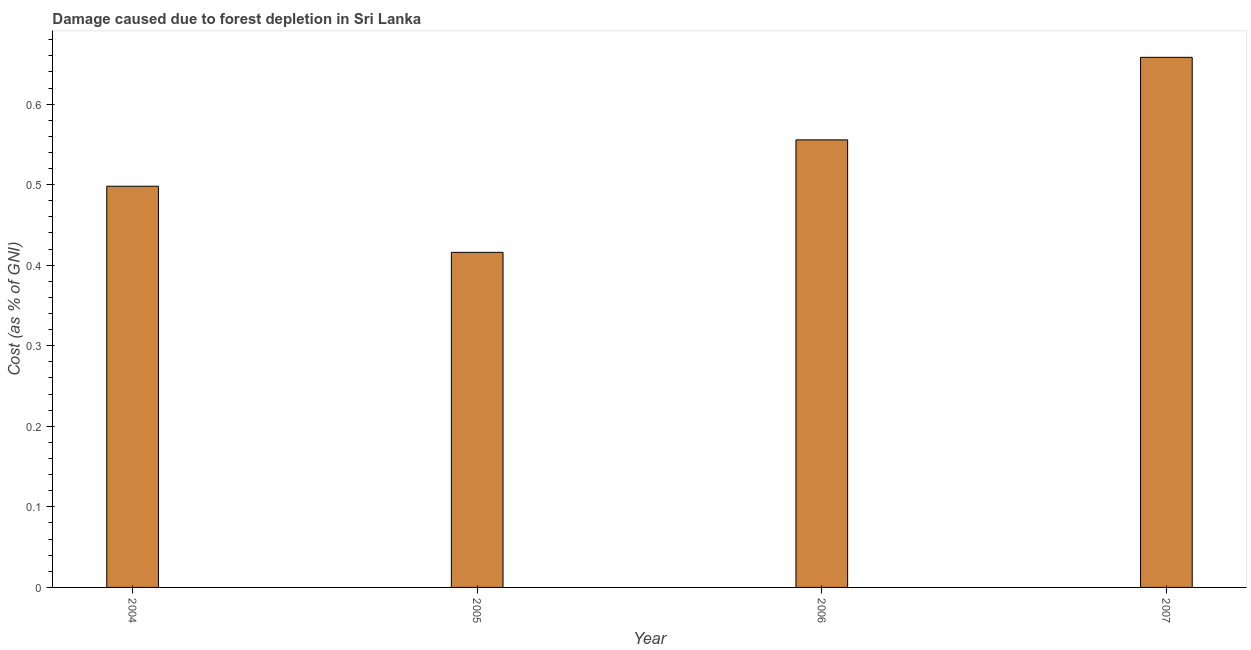What is the title of the graph?
Offer a very short reply. Damage caused due to forest depletion in Sri Lanka. What is the label or title of the X-axis?
Offer a very short reply. Year. What is the label or title of the Y-axis?
Keep it short and to the point. Cost (as % of GNI). What is the damage caused due to forest depletion in 2007?
Your response must be concise. 0.66. Across all years, what is the maximum damage caused due to forest depletion?
Your response must be concise. 0.66. Across all years, what is the minimum damage caused due to forest depletion?
Your answer should be compact. 0.42. What is the sum of the damage caused due to forest depletion?
Provide a short and direct response. 2.13. What is the difference between the damage caused due to forest depletion in 2004 and 2007?
Provide a succinct answer. -0.16. What is the average damage caused due to forest depletion per year?
Provide a succinct answer. 0.53. What is the median damage caused due to forest depletion?
Make the answer very short. 0.53. In how many years, is the damage caused due to forest depletion greater than 0.38 %?
Give a very brief answer. 4. What is the ratio of the damage caused due to forest depletion in 2006 to that in 2007?
Keep it short and to the point. 0.84. Is the difference between the damage caused due to forest depletion in 2004 and 2006 greater than the difference between any two years?
Ensure brevity in your answer.  No. What is the difference between the highest and the second highest damage caused due to forest depletion?
Provide a succinct answer. 0.1. Is the sum of the damage caused due to forest depletion in 2004 and 2007 greater than the maximum damage caused due to forest depletion across all years?
Provide a short and direct response. Yes. What is the difference between the highest and the lowest damage caused due to forest depletion?
Ensure brevity in your answer.  0.24. How many bars are there?
Offer a terse response. 4. Are all the bars in the graph horizontal?
Your response must be concise. No. Are the values on the major ticks of Y-axis written in scientific E-notation?
Your response must be concise. No. What is the Cost (as % of GNI) of 2004?
Ensure brevity in your answer.  0.5. What is the Cost (as % of GNI) of 2005?
Your response must be concise. 0.42. What is the Cost (as % of GNI) of 2006?
Give a very brief answer. 0.56. What is the Cost (as % of GNI) of 2007?
Provide a short and direct response. 0.66. What is the difference between the Cost (as % of GNI) in 2004 and 2005?
Ensure brevity in your answer.  0.08. What is the difference between the Cost (as % of GNI) in 2004 and 2006?
Give a very brief answer. -0.06. What is the difference between the Cost (as % of GNI) in 2004 and 2007?
Provide a short and direct response. -0.16. What is the difference between the Cost (as % of GNI) in 2005 and 2006?
Keep it short and to the point. -0.14. What is the difference between the Cost (as % of GNI) in 2005 and 2007?
Keep it short and to the point. -0.24. What is the difference between the Cost (as % of GNI) in 2006 and 2007?
Ensure brevity in your answer.  -0.1. What is the ratio of the Cost (as % of GNI) in 2004 to that in 2005?
Keep it short and to the point. 1.2. What is the ratio of the Cost (as % of GNI) in 2004 to that in 2006?
Keep it short and to the point. 0.9. What is the ratio of the Cost (as % of GNI) in 2004 to that in 2007?
Ensure brevity in your answer.  0.76. What is the ratio of the Cost (as % of GNI) in 2005 to that in 2006?
Offer a terse response. 0.75. What is the ratio of the Cost (as % of GNI) in 2005 to that in 2007?
Your answer should be compact. 0.63. What is the ratio of the Cost (as % of GNI) in 2006 to that in 2007?
Your answer should be very brief. 0.84. 